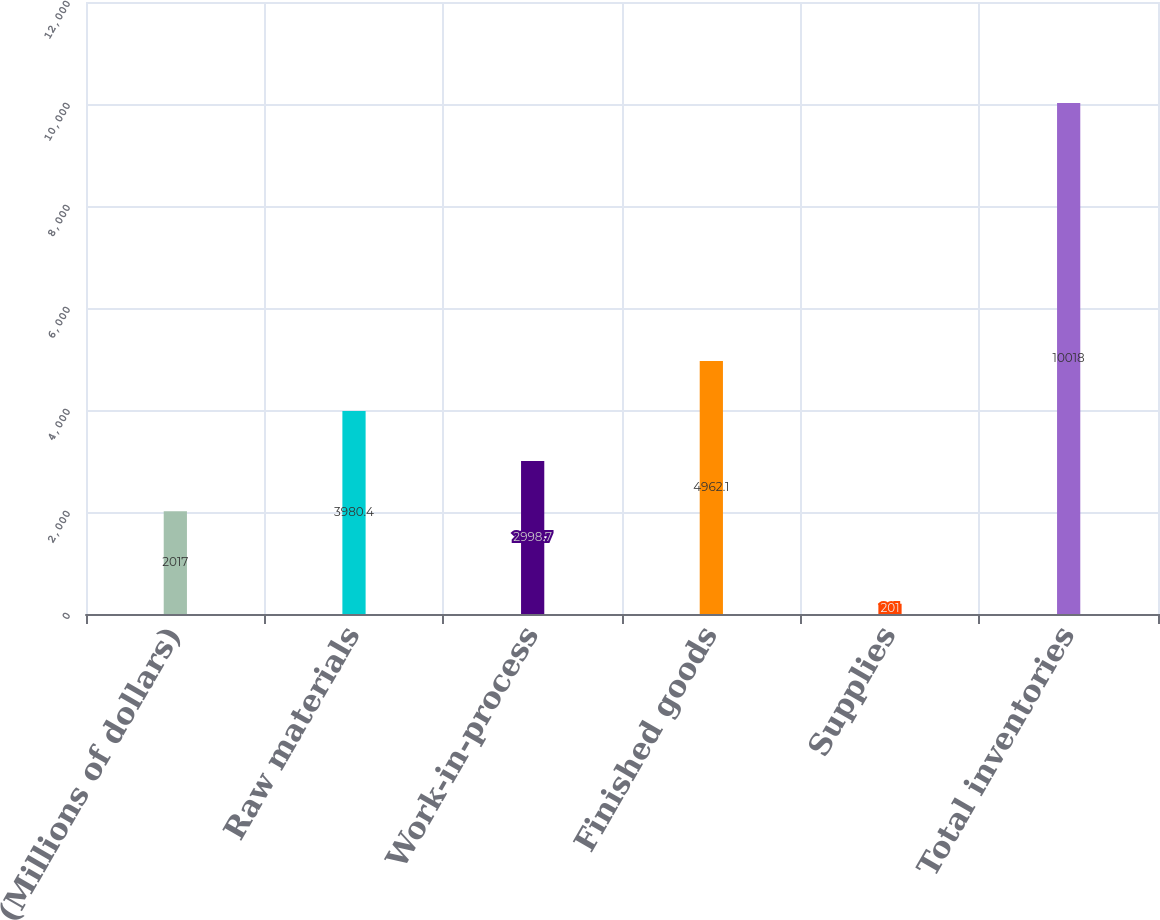<chart> <loc_0><loc_0><loc_500><loc_500><bar_chart><fcel>(Millions of dollars)<fcel>Raw materials<fcel>Work-in-process<fcel>Finished goods<fcel>Supplies<fcel>Total inventories<nl><fcel>2017<fcel>3980.4<fcel>2998.7<fcel>4962.1<fcel>201<fcel>10018<nl></chart> 